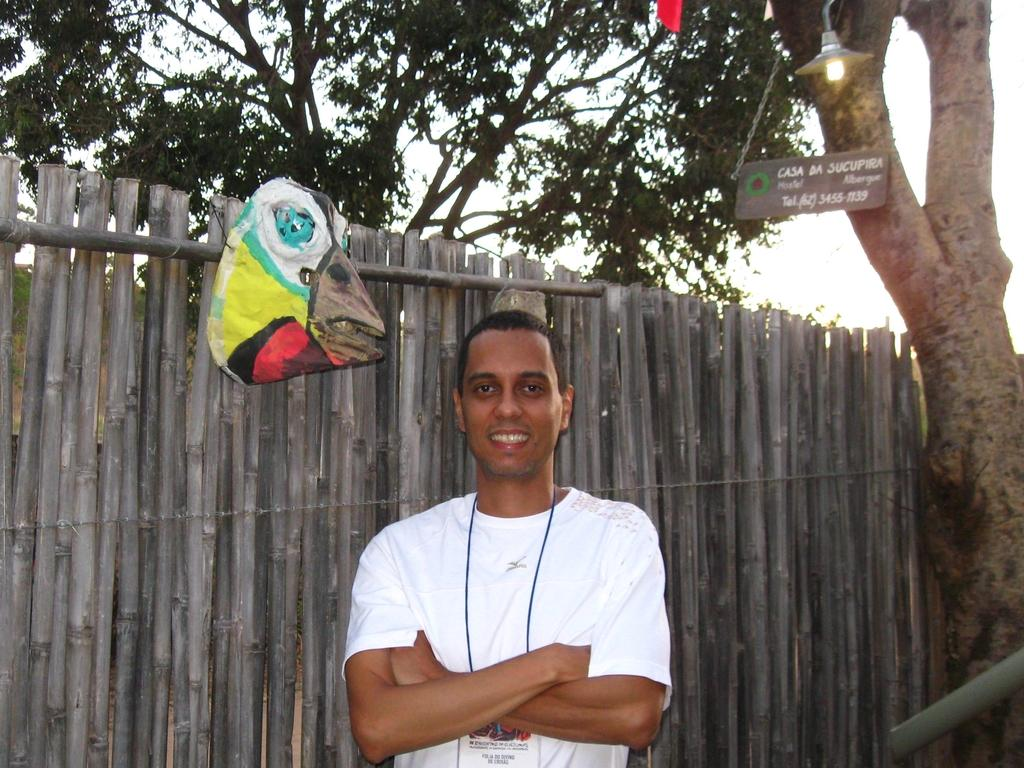What is the main subject of the image? There is a man in the image. What is the man wearing? The man is wearing a white t-shirt. Where is the man standing? The man is standing in front of a wooden fence. What can be seen hanging on the wooden fence? There is a bag hanging on the wooden fence. What type of vegetation is present on either side of the wooden fence? Trees are present on either side of the wooden fence. What type of ship can be seen sailing in the background of the image? There is no ship visible in the image; it features a man standing in front of a wooden fence with trees on either side. 